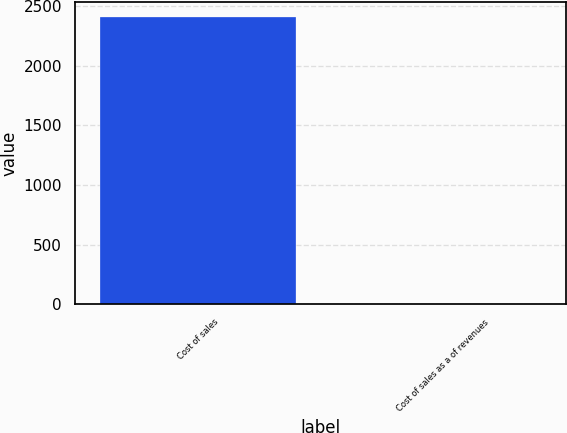<chart> <loc_0><loc_0><loc_500><loc_500><bar_chart><fcel>Cost of sales<fcel>Cost of sales as a of revenues<nl><fcel>2414<fcel>3<nl></chart> 